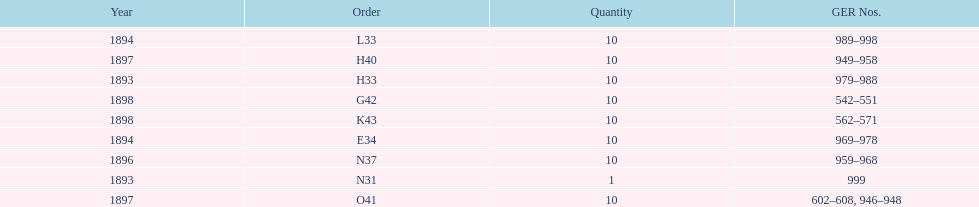What is the first item displayed at the beginning of the table? N31. 